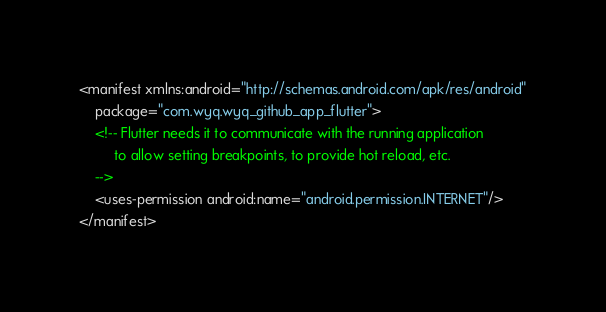<code> <loc_0><loc_0><loc_500><loc_500><_XML_><manifest xmlns:android="http://schemas.android.com/apk/res/android"
    package="com.wyq.wyq_github_app_flutter">
    <!-- Flutter needs it to communicate with the running application
         to allow setting breakpoints, to provide hot reload, etc.
    -->
    <uses-permission android:name="android.permission.INTERNET"/>
</manifest>
</code> 